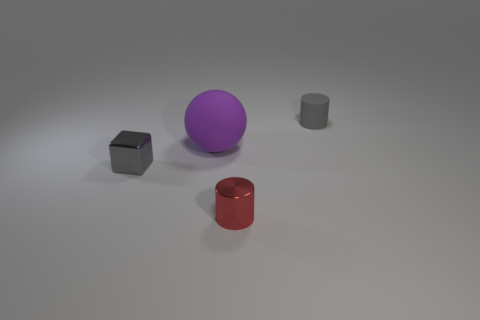What is the color of the shiny object that is to the left of the object that is in front of the tiny gray metallic block?
Provide a succinct answer. Gray. Are there any small blocks that have the same color as the tiny rubber cylinder?
Your response must be concise. Yes. There is a matte thing on the left side of the cylinder that is behind the tiny cylinder in front of the tiny rubber cylinder; what is its size?
Offer a terse response. Large. Is the shape of the tiny red metallic thing the same as the thing right of the small red cylinder?
Keep it short and to the point. Yes. What number of other things are the same size as the purple matte sphere?
Provide a succinct answer. 0. There is a cylinder behind the large ball; what is its size?
Offer a very short reply. Small. What number of small gray cylinders are the same material as the sphere?
Your answer should be very brief. 1. There is a tiny shiny object on the right side of the purple rubber object; is it the same shape as the gray rubber thing?
Offer a terse response. Yes. The rubber thing that is to the left of the small gray rubber cylinder has what shape?
Make the answer very short. Sphere. There is a metallic object that is the same color as the tiny matte object; what is its size?
Your answer should be compact. Small. 